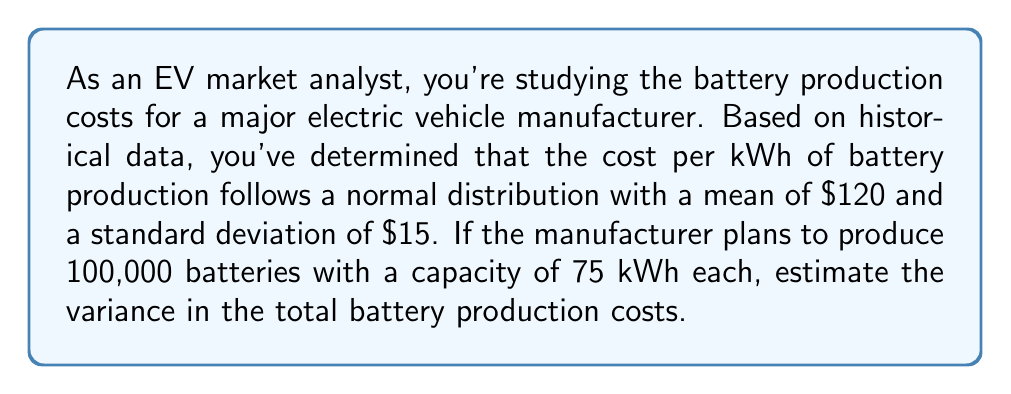Can you answer this question? Let's approach this step-by-step:

1) First, we need to understand what we're calculating. We're looking for the variance of the total production cost for all batteries.

2) Let $X$ be the random variable representing the cost per kWh. We're given that:
   $X \sim N(\mu = 120, \sigma = 15)$

3) For each battery, we need 75 kWh. So the cost for one battery is 75X.

4) The total cost for all 100,000 batteries is 75X * 100,000 = 7,500,000X

5) We need to find $Var(7,500,000X)$

6) Recall the property of variance: $Var(aX) = a^2 * Var(X)$, where $a$ is a constant.

7) In this case, $a = 7,500,000$

8) We know that for a normal distribution, $Var(X) = \sigma^2 = 15^2 = 225$

9) Therefore:
   $$Var(7,500,000X) = (7,500,000)^2 * Var(X)$$
   $$= (7,500,000)^2 * 225$$
   $$= 12,656,250,000,000,000$$

10) This gives us the variance in dollars squared. To make it more interpretable, we can take the square root to get the standard deviation in dollars:
    $$\sqrt{12,656,250,000,000,000} = 3,543,750,000$$
Answer: $12,656,250,000,000,000 (variance in $^2)$ or $3,543,750,000 (standard deviation in $)$ 